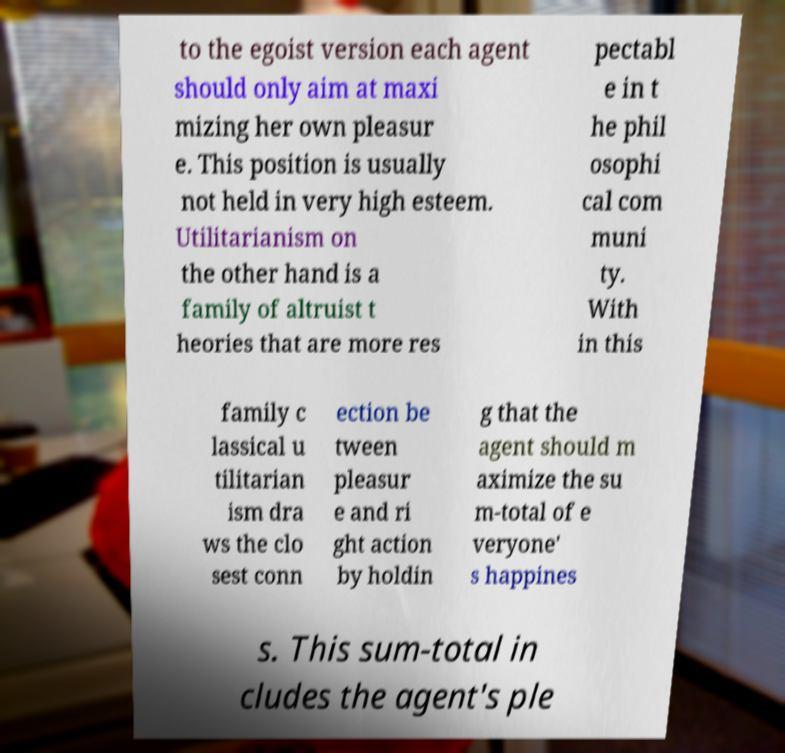For documentation purposes, I need the text within this image transcribed. Could you provide that? to the egoist version each agent should only aim at maxi mizing her own pleasur e. This position is usually not held in very high esteem. Utilitarianism on the other hand is a family of altruist t heories that are more res pectabl e in t he phil osophi cal com muni ty. With in this family c lassical u tilitarian ism dra ws the clo sest conn ection be tween pleasur e and ri ght action by holdin g that the agent should m aximize the su m-total of e veryone' s happines s. This sum-total in cludes the agent's ple 